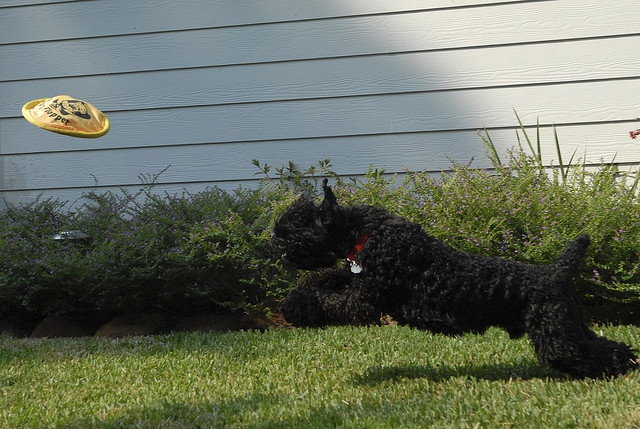Describe the objects in this image and their specific colors. I can see dog in gray, black, and darkgreen tones and frisbee in gray, khaki, tan, and olive tones in this image. 